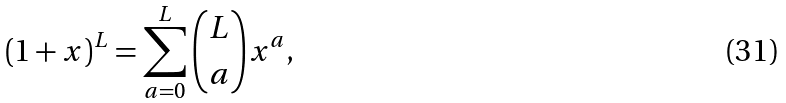Convert formula to latex. <formula><loc_0><loc_0><loc_500><loc_500>( 1 + x ) ^ { L } = \sum _ { a = 0 } ^ { L } \binom { L } { a } x ^ { a } ,</formula> 